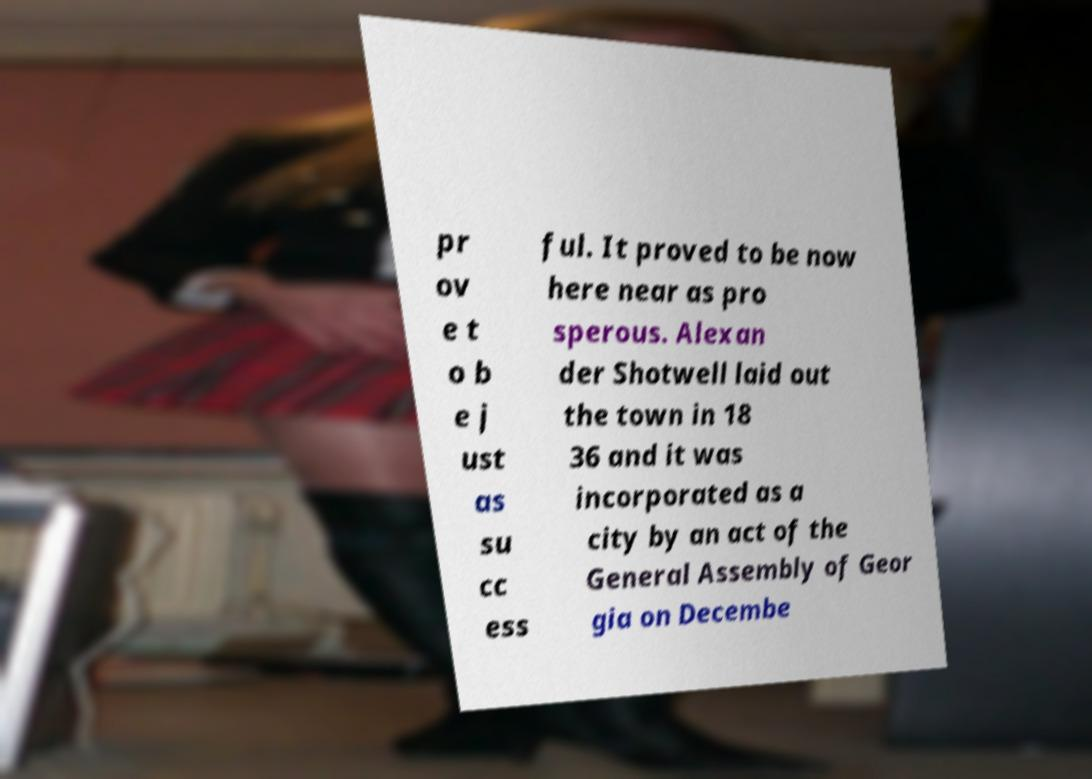I need the written content from this picture converted into text. Can you do that? pr ov e t o b e j ust as su cc ess ful. It proved to be now here near as pro sperous. Alexan der Shotwell laid out the town in 18 36 and it was incorporated as a city by an act of the General Assembly of Geor gia on Decembe 